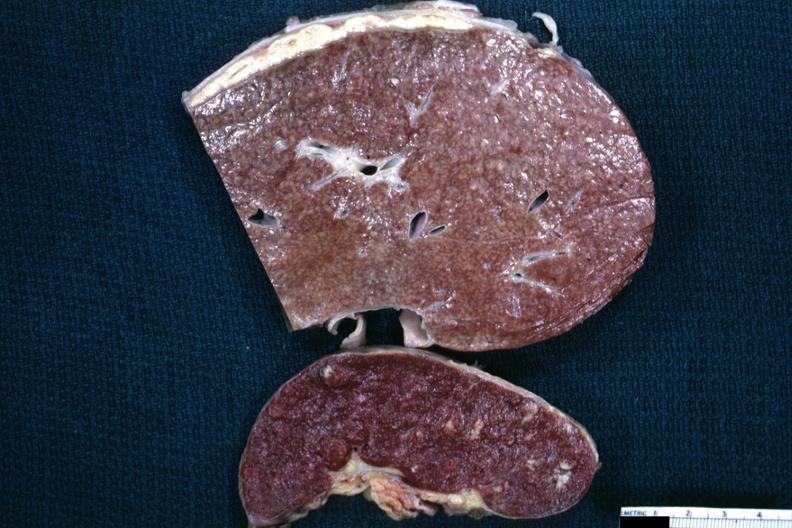what is present on capsule of liver and spleen?
Answer the question using a single word or phrase. Typical tuberculous exudate 